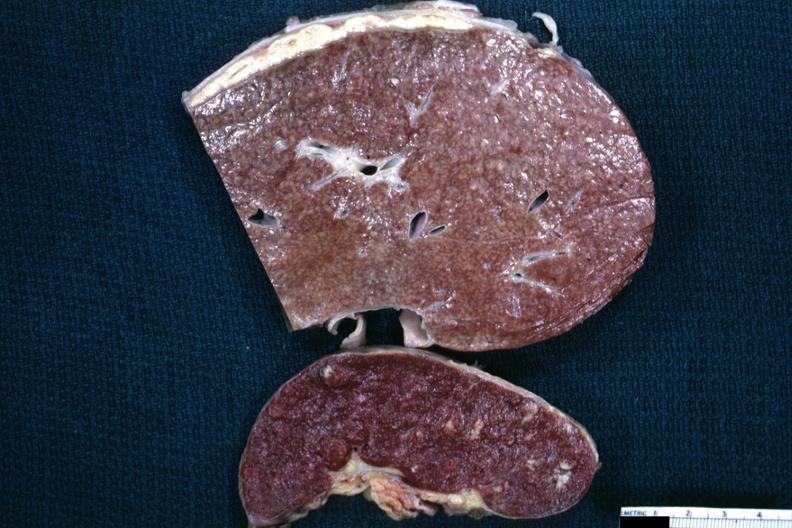what is present on capsule of liver and spleen?
Answer the question using a single word or phrase. Typical tuberculous exudate 